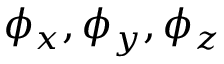<formula> <loc_0><loc_0><loc_500><loc_500>\phi _ { x } , \phi _ { y } , \phi _ { z }</formula> 